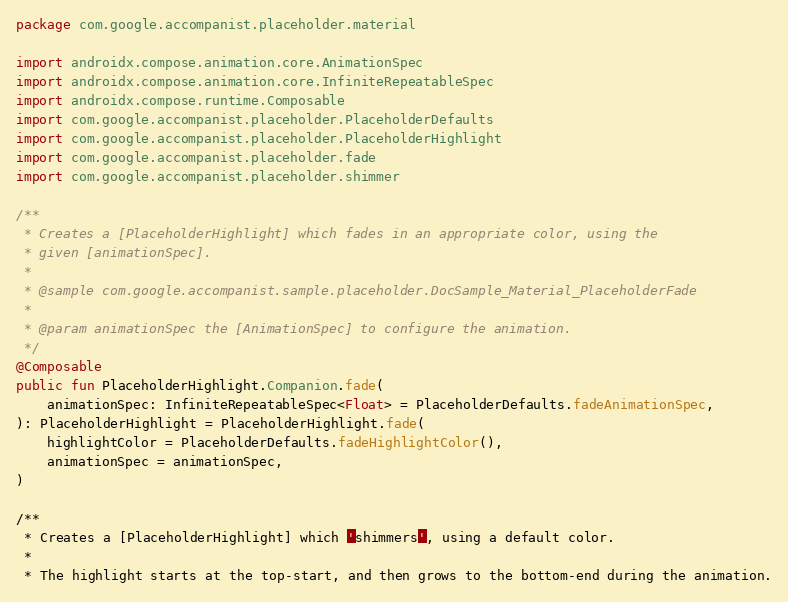<code> <loc_0><loc_0><loc_500><loc_500><_Kotlin_>package com.google.accompanist.placeholder.material

import androidx.compose.animation.core.AnimationSpec
import androidx.compose.animation.core.InfiniteRepeatableSpec
import androidx.compose.runtime.Composable
import com.google.accompanist.placeholder.PlaceholderDefaults
import com.google.accompanist.placeholder.PlaceholderHighlight
import com.google.accompanist.placeholder.fade
import com.google.accompanist.placeholder.shimmer

/**
 * Creates a [PlaceholderHighlight] which fades in an appropriate color, using the
 * given [animationSpec].
 *
 * @sample com.google.accompanist.sample.placeholder.DocSample_Material_PlaceholderFade
 *
 * @param animationSpec the [AnimationSpec] to configure the animation.
 */
@Composable
public fun PlaceholderHighlight.Companion.fade(
    animationSpec: InfiniteRepeatableSpec<Float> = PlaceholderDefaults.fadeAnimationSpec,
): PlaceholderHighlight = PlaceholderHighlight.fade(
    highlightColor = PlaceholderDefaults.fadeHighlightColor(),
    animationSpec = animationSpec,
)

/**
 * Creates a [PlaceholderHighlight] which 'shimmers', using a default color.
 *
 * The highlight starts at the top-start, and then grows to the bottom-end during the animation.</code> 